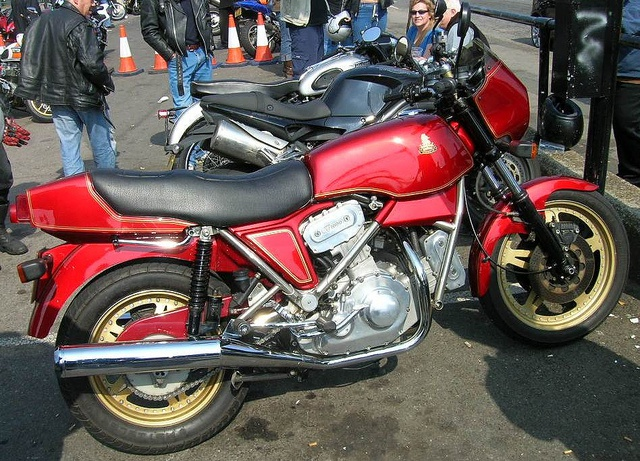Describe the objects in this image and their specific colors. I can see motorcycle in gray, black, white, and darkgray tones, motorcycle in gray, black, white, and darkgray tones, people in gray, black, and blue tones, people in gray, black, lightblue, and navy tones, and people in gray, black, blue, and darkblue tones in this image. 